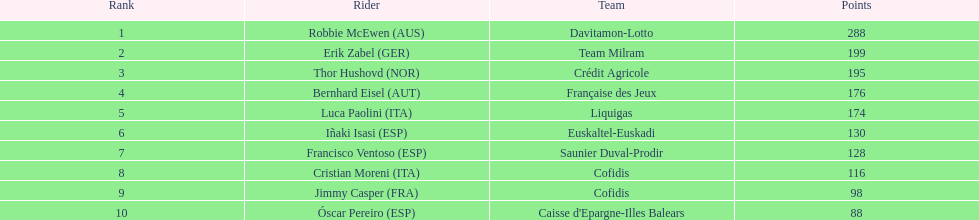How many additional points did erik zabel achieve compared to francisco ventoso? 71. 